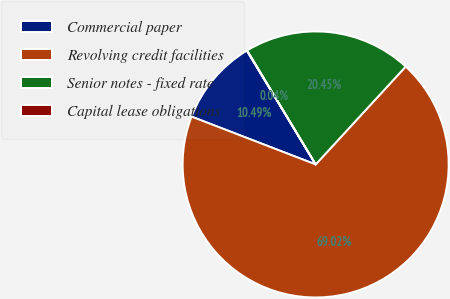Convert chart. <chart><loc_0><loc_0><loc_500><loc_500><pie_chart><fcel>Commercial paper<fcel>Revolving credit facilities<fcel>Senior notes - fixed rate<fcel>Capital lease obligations<nl><fcel>10.49%<fcel>69.02%<fcel>20.45%<fcel>0.04%<nl></chart> 